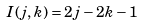<formula> <loc_0><loc_0><loc_500><loc_500>I ( j , k ) = 2 j - 2 k - 1</formula> 